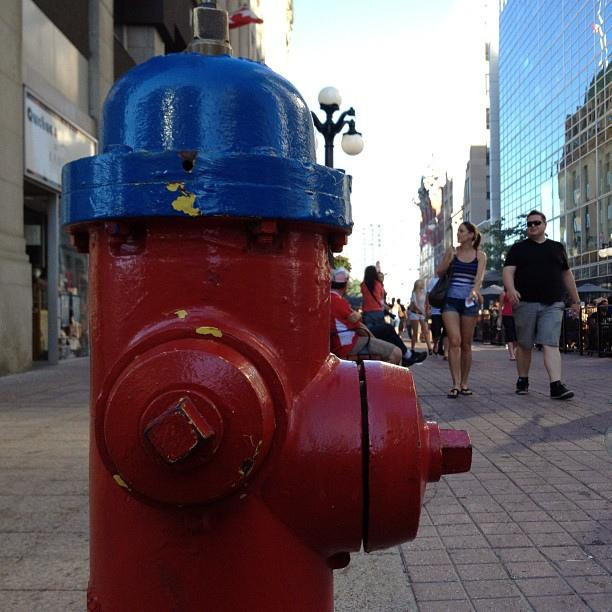What cannot be done in front of this object?

Choices:
A) singing
B) parking
C) eating
D) walking parking 